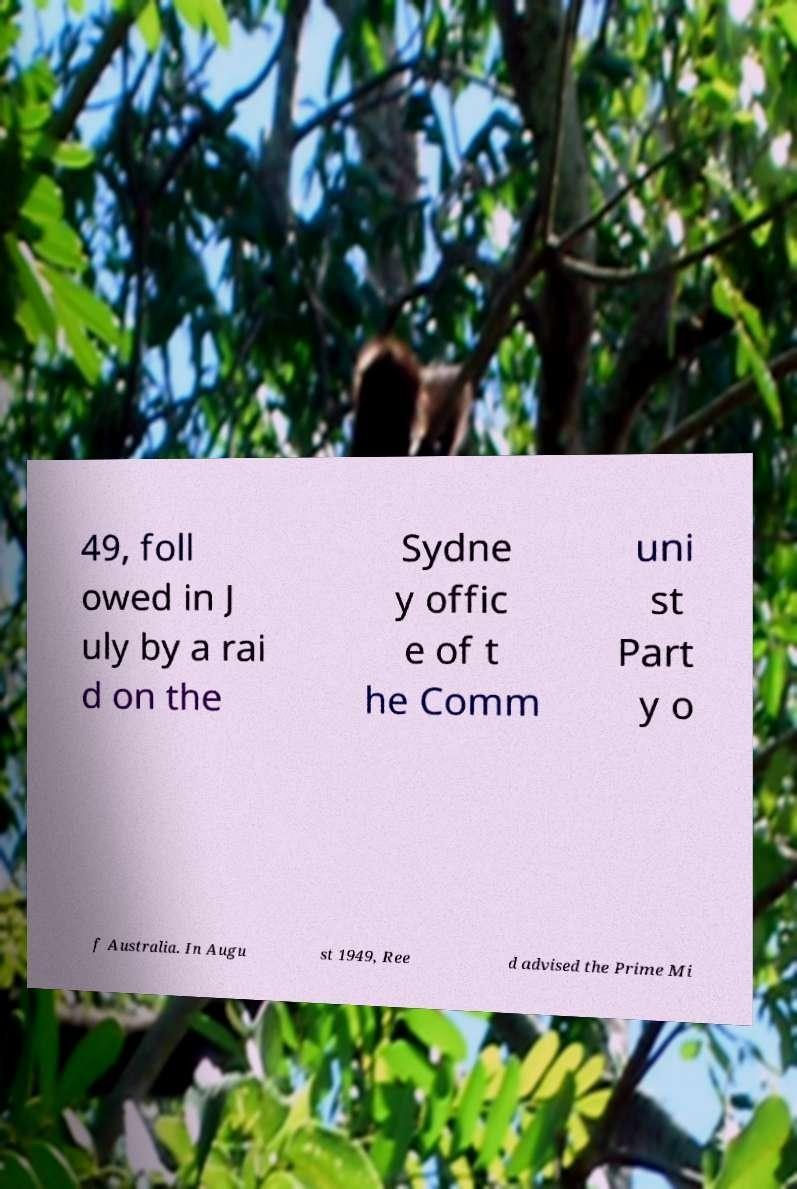Can you accurately transcribe the text from the provided image for me? 49, foll owed in J uly by a rai d on the Sydne y offic e of t he Comm uni st Part y o f Australia. In Augu st 1949, Ree d advised the Prime Mi 